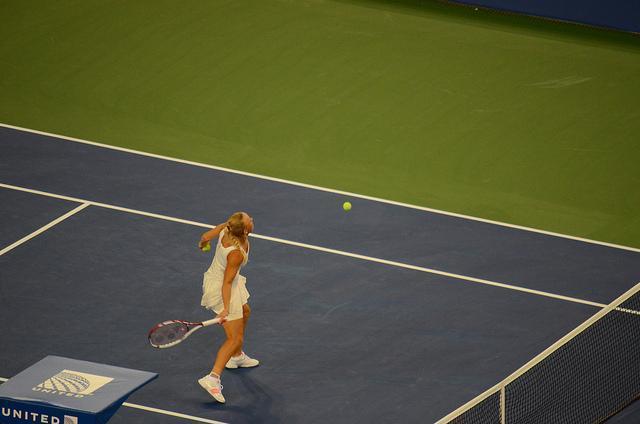How many of the surfboards are yellow?
Give a very brief answer. 0. 